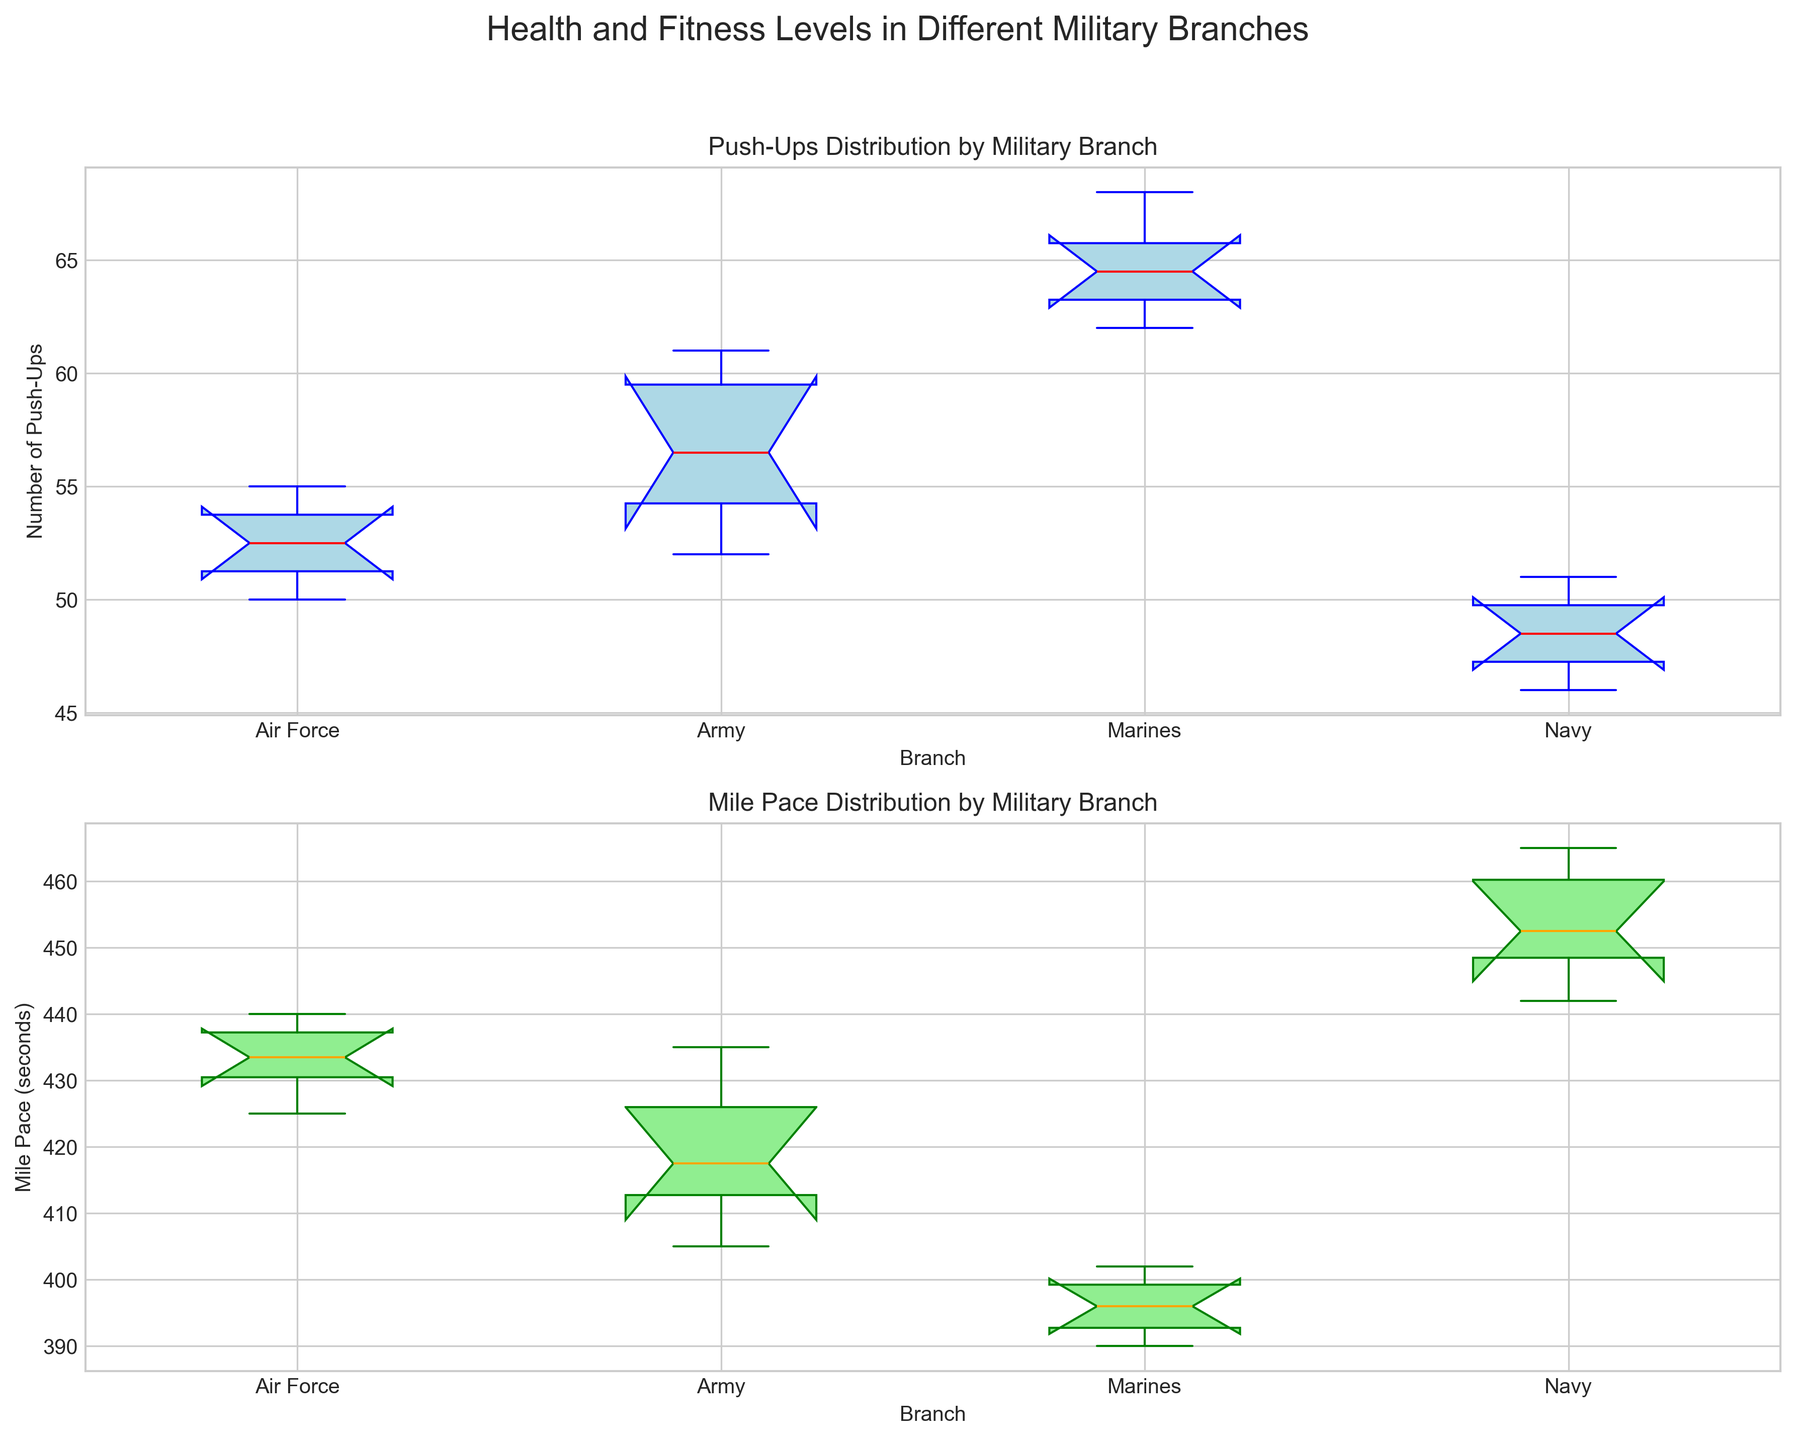Which branch has the highest median number of push-ups? Look at the box plot for push-ups and identify the branch with the highest red median line. The Marines have the highest push-ups median.
Answer: Marines How does the median mile pace for the Navy compare to that of the Army? Compare the position of the orange median lines in the mile pace box plot for the Navy and the Army. The Navy’s median mile pace is slower than the Army's, indicating a higher median value in seconds.
Answer: Navy is slower than Army What is the range of push-ups for the Marine Corps? To find the range, subtract the minimum push-ups value (lower whisker) from the maximum push-ups value (upper whisker) in the Marines box plot. The whiskers extend from 62 to 68 push-ups.
Answer: 6 push-ups (68 - 62) Which branch has the smallest interquartile range (IQR) for mile pace? Compare the length of the boxes in the mile pace box plot. The branch with the shortest box has the smallest IQR. The Marines have the smallest IQR as their box is the shortest.
Answer: Marines How do the upper quartile mile pace times of the Air Force compare to the Navy? Look at the top edge of the boxes (upper quartile) for the Air Force and Navy in the mile pace box plot. The Air Force's upper quartile is less than the Navy’s, indicating a faster pace.
Answer: Air Force is faster than Navy Based on the box plots, which branch has the most consistent push-up performance? Consistency can be inferred from the smallest IQR, i.e., the shortest box in the push-ups plot. The Marines have the shortest box, indicating they have the most consistent performance.
Answer: Marines What is the visual difference in the median lines' color for push-ups and mile pace? Observe the median lines in both plots. The median for push-ups is red and the median for mile pace is orange.
Answer: Push-ups median is red; mile pace median is orange Which branch shows the least variability in their mile pace? Least variability can be visualized by the length of the whiskers and the box. The Marines have the shortest box and whiskers in the mile pace box plot.
Answer: Marines If we consider the median number of push-ups as a measure of upper-body strength, which branch would you infer has the highest upper-body strength? Identify the branch with the highest median line in the push-ups box plot. The Marines have the highest median.
Answer: Marines 